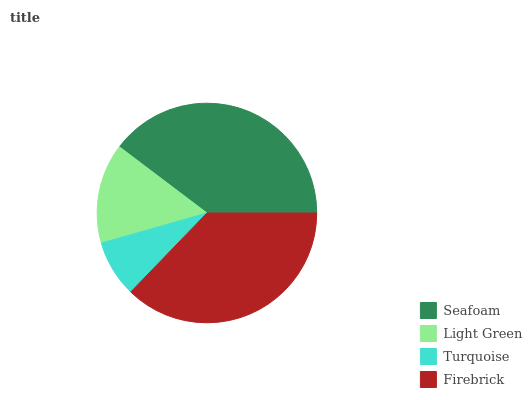Is Turquoise the minimum?
Answer yes or no. Yes. Is Seafoam the maximum?
Answer yes or no. Yes. Is Light Green the minimum?
Answer yes or no. No. Is Light Green the maximum?
Answer yes or no. No. Is Seafoam greater than Light Green?
Answer yes or no. Yes. Is Light Green less than Seafoam?
Answer yes or no. Yes. Is Light Green greater than Seafoam?
Answer yes or no. No. Is Seafoam less than Light Green?
Answer yes or no. No. Is Firebrick the high median?
Answer yes or no. Yes. Is Light Green the low median?
Answer yes or no. Yes. Is Light Green the high median?
Answer yes or no. No. Is Seafoam the low median?
Answer yes or no. No. 